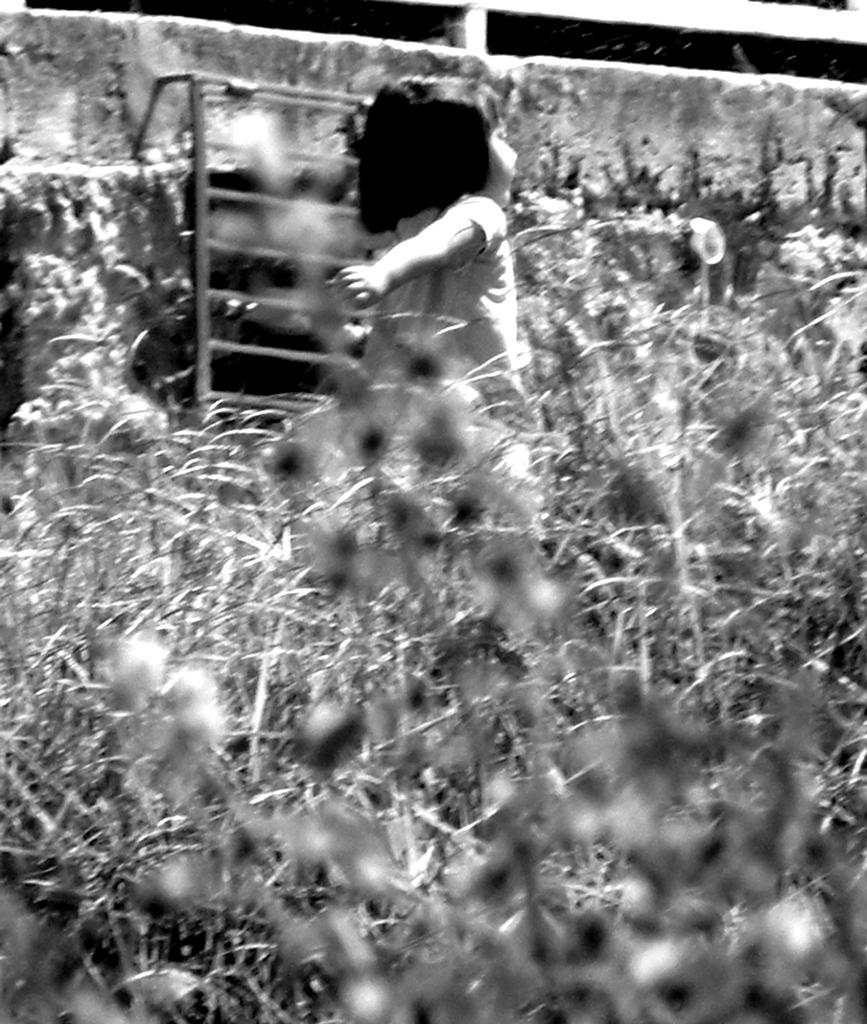Who is the main subject in the image? There is a small girl in the center of the image. What can be seen at the bottom side of the image? There are plants at the bottom side of the image. Reasoning: Let's think step by step by step in order to produce the conversation. We start by identifying the main subject in the image, which is the small girl. Then, we expand the conversation to include the plants at the bottom side of the image as another important detail. Each question is designed to elicit a specific detail about the image that is known from the provided facts. Absurd Question/Answer: What type of plane is flying over the girl in the image? There is no plane visible in the image; it only features a small girl and plants. What religion is the girl practicing in the image? There is no indication of any religious activity or belief in the image; it only shows a small girl and plants. 